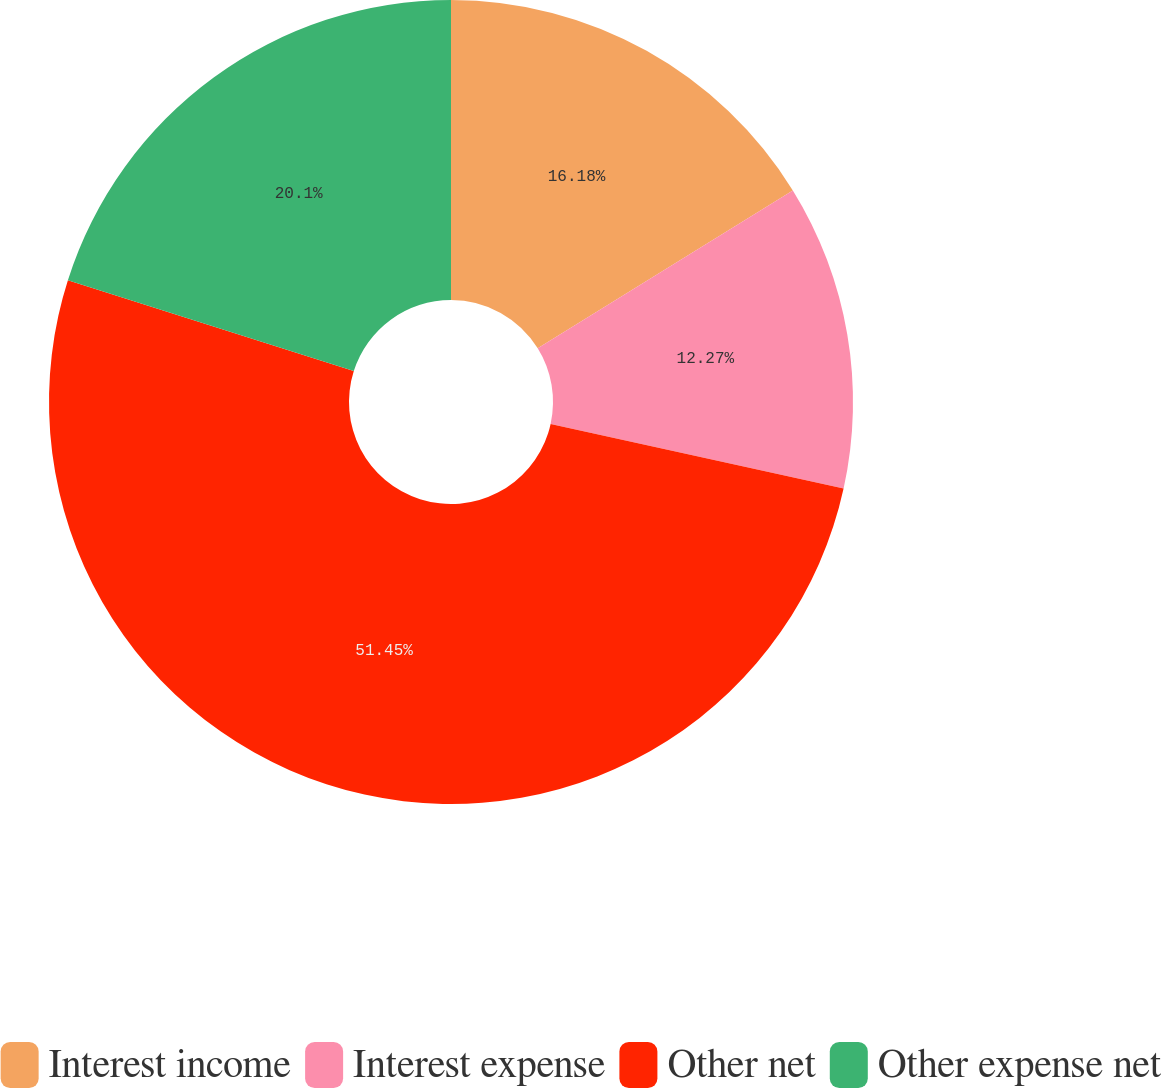Convert chart. <chart><loc_0><loc_0><loc_500><loc_500><pie_chart><fcel>Interest income<fcel>Interest expense<fcel>Other net<fcel>Other expense net<nl><fcel>16.18%<fcel>12.27%<fcel>51.45%<fcel>20.1%<nl></chart> 